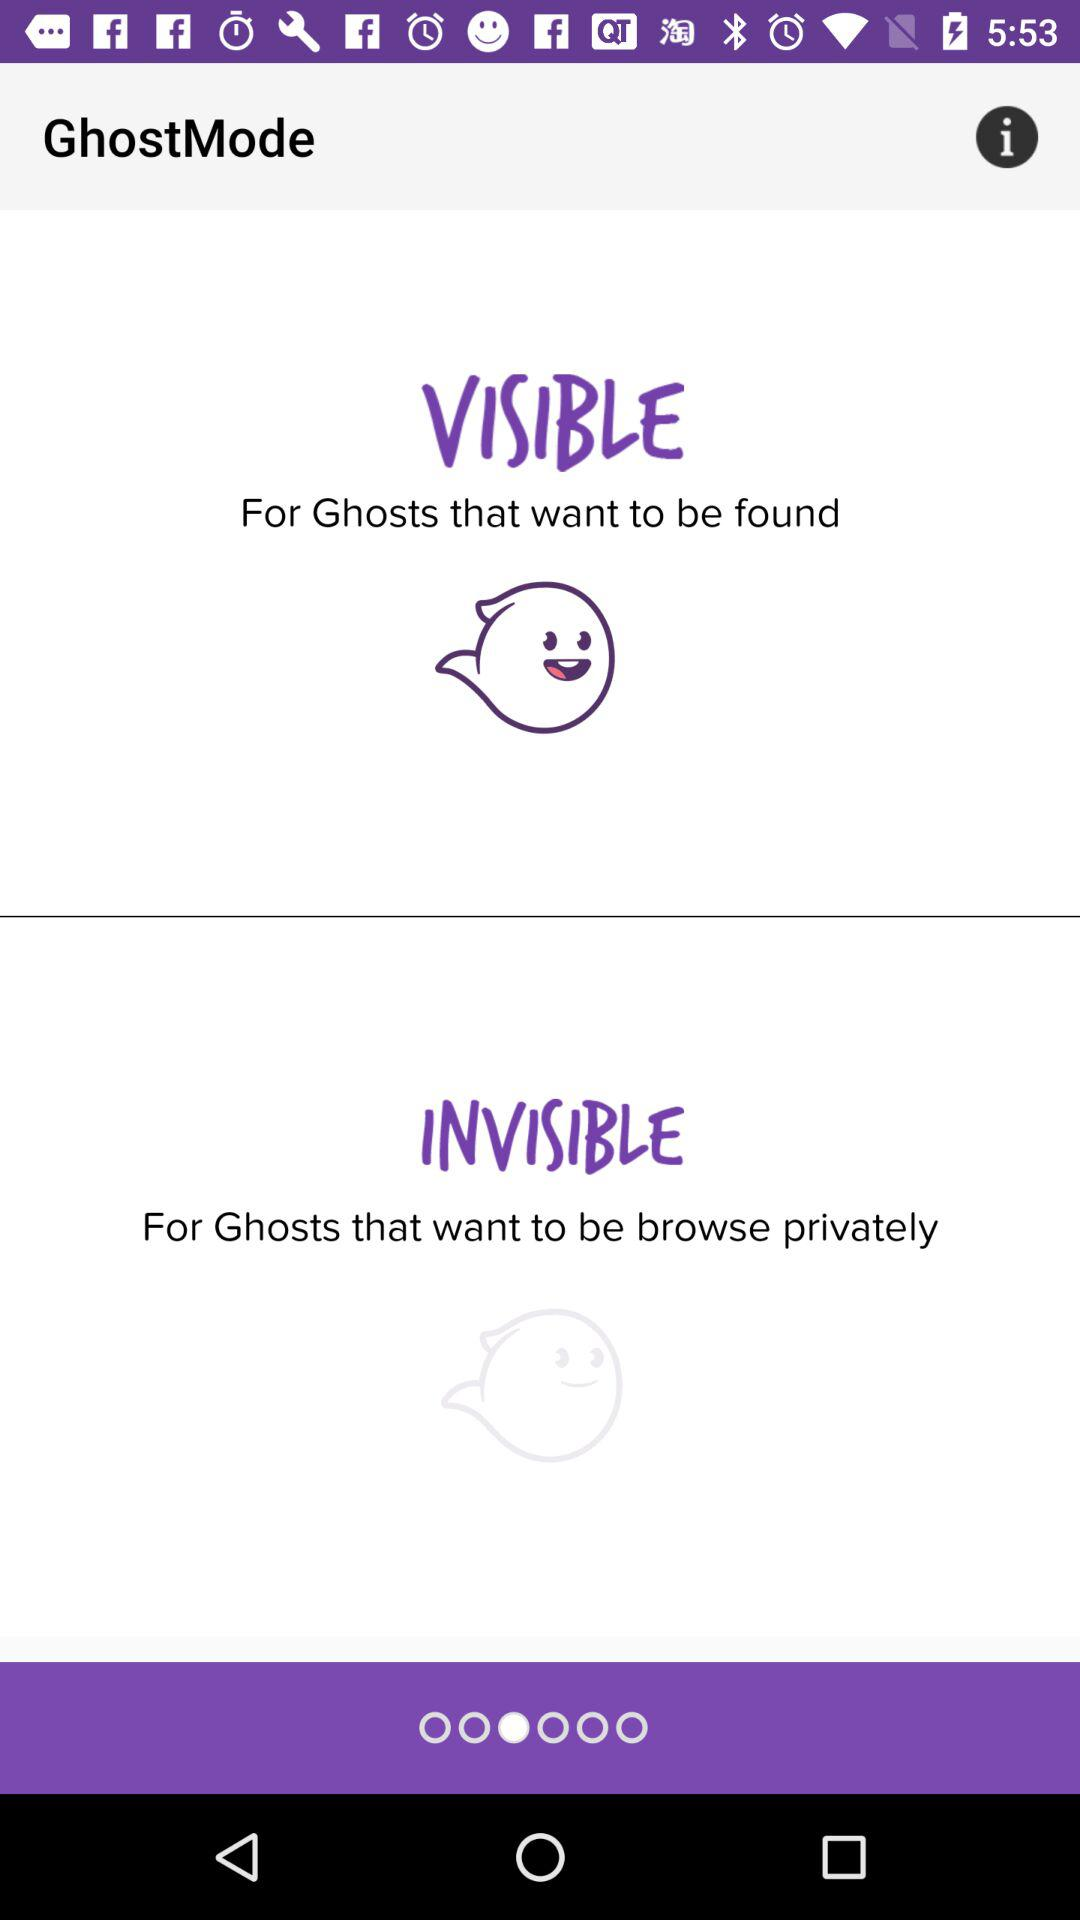What is the name of the application? The name of the application is GhostMode. 